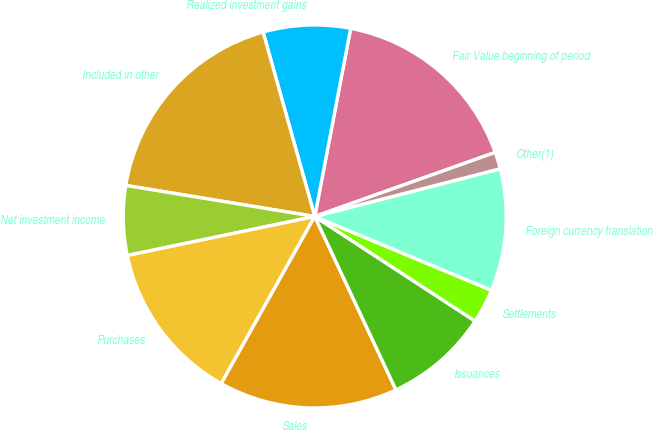Convert chart. <chart><loc_0><loc_0><loc_500><loc_500><pie_chart><fcel>Fair Value beginning of period<fcel>Realized investment gains<fcel>Included in other<fcel>Net investment income<fcel>Purchases<fcel>Sales<fcel>Issuances<fcel>Settlements<fcel>Foreign currency translation<fcel>Other(1)<nl><fcel>16.57%<fcel>7.35%<fcel>18.06%<fcel>5.86%<fcel>13.61%<fcel>15.09%<fcel>8.83%<fcel>2.9%<fcel>10.31%<fcel>1.42%<nl></chart> 